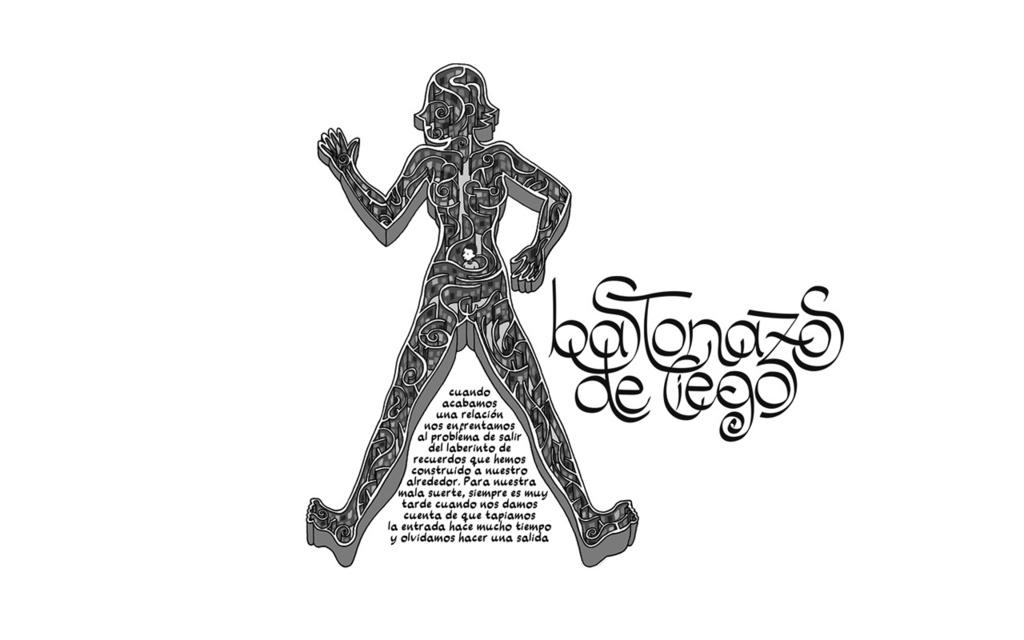What is the main subject of the image? There is a painted picture in the image. What does the painting depict? The painting depicts a person. Are there any words or letters in the image? Yes, there is some text in the image. What color is the background of the image? The background of the image is white. How many fingers can be seen on the person in the painting? There is no information about the person's fingers in the image, as it only shows a painted picture of a person. Is there a tub visible in the image? No, there is no tub present in the image. 